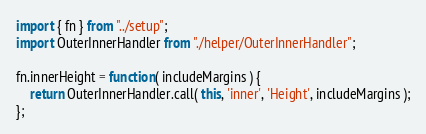Convert code to text. <code><loc_0><loc_0><loc_500><loc_500><_JavaScript_>import { fn } from "../setup";
import OuterInnerHandler from "./helper/OuterInnerHandler";

fn.innerHeight = function( includeMargins ) {
	return OuterInnerHandler.call( this, 'inner', 'Height', includeMargins );
};
</code> 